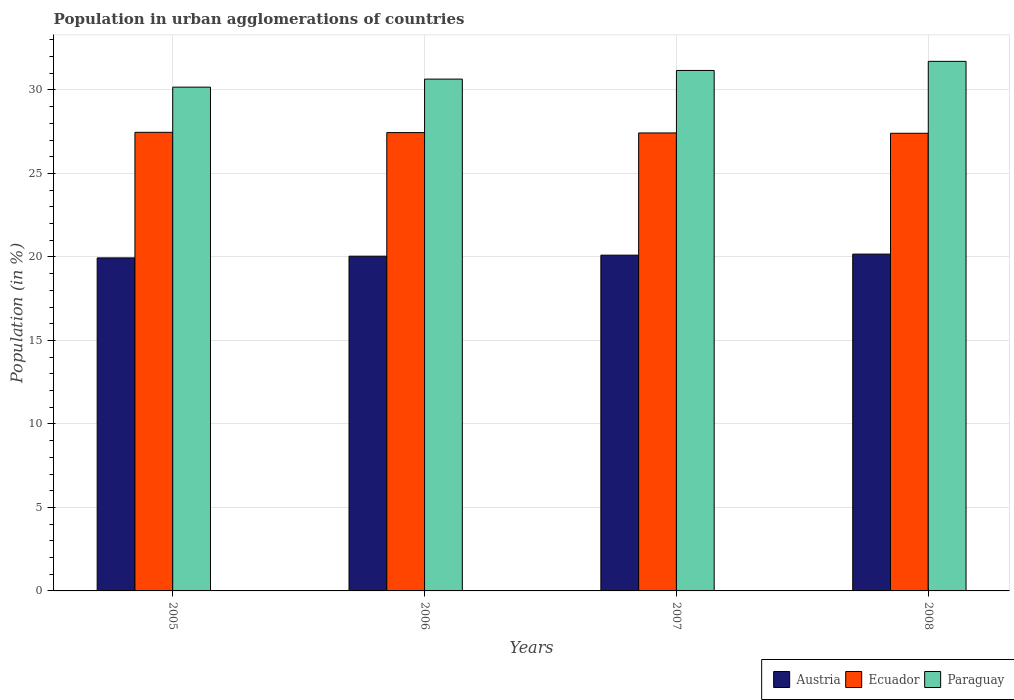How many different coloured bars are there?
Your answer should be compact. 3. How many groups of bars are there?
Your answer should be compact. 4. Are the number of bars on each tick of the X-axis equal?
Your response must be concise. Yes. What is the label of the 2nd group of bars from the left?
Keep it short and to the point. 2006. In how many cases, is the number of bars for a given year not equal to the number of legend labels?
Ensure brevity in your answer.  0. What is the percentage of population in urban agglomerations in Austria in 2007?
Your answer should be compact. 20.11. Across all years, what is the maximum percentage of population in urban agglomerations in Austria?
Your response must be concise. 20.17. Across all years, what is the minimum percentage of population in urban agglomerations in Paraguay?
Offer a terse response. 30.17. In which year was the percentage of population in urban agglomerations in Ecuador maximum?
Your answer should be very brief. 2005. What is the total percentage of population in urban agglomerations in Austria in the graph?
Give a very brief answer. 80.27. What is the difference between the percentage of population in urban agglomerations in Austria in 2005 and that in 2008?
Your response must be concise. -0.23. What is the difference between the percentage of population in urban agglomerations in Paraguay in 2007 and the percentage of population in urban agglomerations in Austria in 2006?
Your response must be concise. 11.12. What is the average percentage of population in urban agglomerations in Ecuador per year?
Give a very brief answer. 27.44. In the year 2005, what is the difference between the percentage of population in urban agglomerations in Ecuador and percentage of population in urban agglomerations in Paraguay?
Keep it short and to the point. -2.71. What is the ratio of the percentage of population in urban agglomerations in Austria in 2005 to that in 2007?
Provide a short and direct response. 0.99. Is the difference between the percentage of population in urban agglomerations in Ecuador in 2007 and 2008 greater than the difference between the percentage of population in urban agglomerations in Paraguay in 2007 and 2008?
Provide a short and direct response. Yes. What is the difference between the highest and the second highest percentage of population in urban agglomerations in Austria?
Offer a very short reply. 0.06. What is the difference between the highest and the lowest percentage of population in urban agglomerations in Ecuador?
Your response must be concise. 0.06. What does the 2nd bar from the right in 2006 represents?
Keep it short and to the point. Ecuador. How many bars are there?
Provide a short and direct response. 12. Are the values on the major ticks of Y-axis written in scientific E-notation?
Give a very brief answer. No. Does the graph contain any zero values?
Keep it short and to the point. No. Where does the legend appear in the graph?
Offer a very short reply. Bottom right. How are the legend labels stacked?
Offer a very short reply. Horizontal. What is the title of the graph?
Your answer should be very brief. Population in urban agglomerations of countries. Does "South Africa" appear as one of the legend labels in the graph?
Provide a succinct answer. No. What is the Population (in %) in Austria in 2005?
Your answer should be very brief. 19.94. What is the Population (in %) in Ecuador in 2005?
Your answer should be compact. 27.46. What is the Population (in %) of Paraguay in 2005?
Offer a terse response. 30.17. What is the Population (in %) in Austria in 2006?
Make the answer very short. 20.05. What is the Population (in %) of Ecuador in 2006?
Your answer should be compact. 27.45. What is the Population (in %) in Paraguay in 2006?
Your response must be concise. 30.65. What is the Population (in %) of Austria in 2007?
Ensure brevity in your answer.  20.11. What is the Population (in %) of Ecuador in 2007?
Your answer should be very brief. 27.43. What is the Population (in %) of Paraguay in 2007?
Your answer should be compact. 31.17. What is the Population (in %) in Austria in 2008?
Offer a terse response. 20.17. What is the Population (in %) in Ecuador in 2008?
Your answer should be very brief. 27.41. What is the Population (in %) of Paraguay in 2008?
Your answer should be compact. 31.72. Across all years, what is the maximum Population (in %) in Austria?
Make the answer very short. 20.17. Across all years, what is the maximum Population (in %) in Ecuador?
Your answer should be very brief. 27.46. Across all years, what is the maximum Population (in %) of Paraguay?
Your response must be concise. 31.72. Across all years, what is the minimum Population (in %) of Austria?
Your answer should be very brief. 19.94. Across all years, what is the minimum Population (in %) in Ecuador?
Your response must be concise. 27.41. Across all years, what is the minimum Population (in %) of Paraguay?
Give a very brief answer. 30.17. What is the total Population (in %) in Austria in the graph?
Offer a very short reply. 80.27. What is the total Population (in %) in Ecuador in the graph?
Your response must be concise. 109.75. What is the total Population (in %) of Paraguay in the graph?
Your answer should be compact. 123.71. What is the difference between the Population (in %) in Austria in 2005 and that in 2006?
Offer a very short reply. -0.1. What is the difference between the Population (in %) in Ecuador in 2005 and that in 2006?
Your response must be concise. 0.02. What is the difference between the Population (in %) of Paraguay in 2005 and that in 2006?
Give a very brief answer. -0.48. What is the difference between the Population (in %) in Austria in 2005 and that in 2007?
Your response must be concise. -0.16. What is the difference between the Population (in %) of Ecuador in 2005 and that in 2007?
Ensure brevity in your answer.  0.04. What is the difference between the Population (in %) of Paraguay in 2005 and that in 2007?
Make the answer very short. -1. What is the difference between the Population (in %) in Austria in 2005 and that in 2008?
Your response must be concise. -0.23. What is the difference between the Population (in %) in Ecuador in 2005 and that in 2008?
Offer a terse response. 0.06. What is the difference between the Population (in %) of Paraguay in 2005 and that in 2008?
Provide a succinct answer. -1.54. What is the difference between the Population (in %) of Austria in 2006 and that in 2007?
Offer a terse response. -0.06. What is the difference between the Population (in %) in Ecuador in 2006 and that in 2007?
Offer a very short reply. 0.02. What is the difference between the Population (in %) in Paraguay in 2006 and that in 2007?
Provide a short and direct response. -0.52. What is the difference between the Population (in %) in Austria in 2006 and that in 2008?
Offer a very short reply. -0.13. What is the difference between the Population (in %) in Ecuador in 2006 and that in 2008?
Keep it short and to the point. 0.04. What is the difference between the Population (in %) in Paraguay in 2006 and that in 2008?
Make the answer very short. -1.06. What is the difference between the Population (in %) in Austria in 2007 and that in 2008?
Make the answer very short. -0.06. What is the difference between the Population (in %) of Ecuador in 2007 and that in 2008?
Make the answer very short. 0.02. What is the difference between the Population (in %) of Paraguay in 2007 and that in 2008?
Offer a very short reply. -0.55. What is the difference between the Population (in %) of Austria in 2005 and the Population (in %) of Ecuador in 2006?
Keep it short and to the point. -7.5. What is the difference between the Population (in %) in Austria in 2005 and the Population (in %) in Paraguay in 2006?
Keep it short and to the point. -10.71. What is the difference between the Population (in %) of Ecuador in 2005 and the Population (in %) of Paraguay in 2006?
Your response must be concise. -3.19. What is the difference between the Population (in %) in Austria in 2005 and the Population (in %) in Ecuador in 2007?
Provide a short and direct response. -7.48. What is the difference between the Population (in %) in Austria in 2005 and the Population (in %) in Paraguay in 2007?
Give a very brief answer. -11.23. What is the difference between the Population (in %) of Ecuador in 2005 and the Population (in %) of Paraguay in 2007?
Your response must be concise. -3.7. What is the difference between the Population (in %) in Austria in 2005 and the Population (in %) in Ecuador in 2008?
Your answer should be compact. -7.46. What is the difference between the Population (in %) of Austria in 2005 and the Population (in %) of Paraguay in 2008?
Offer a terse response. -11.77. What is the difference between the Population (in %) in Ecuador in 2005 and the Population (in %) in Paraguay in 2008?
Keep it short and to the point. -4.25. What is the difference between the Population (in %) in Austria in 2006 and the Population (in %) in Ecuador in 2007?
Your answer should be very brief. -7.38. What is the difference between the Population (in %) of Austria in 2006 and the Population (in %) of Paraguay in 2007?
Ensure brevity in your answer.  -11.12. What is the difference between the Population (in %) in Ecuador in 2006 and the Population (in %) in Paraguay in 2007?
Your answer should be compact. -3.72. What is the difference between the Population (in %) in Austria in 2006 and the Population (in %) in Ecuador in 2008?
Your answer should be very brief. -7.36. What is the difference between the Population (in %) of Austria in 2006 and the Population (in %) of Paraguay in 2008?
Offer a terse response. -11.67. What is the difference between the Population (in %) in Ecuador in 2006 and the Population (in %) in Paraguay in 2008?
Keep it short and to the point. -4.27. What is the difference between the Population (in %) in Austria in 2007 and the Population (in %) in Ecuador in 2008?
Provide a short and direct response. -7.3. What is the difference between the Population (in %) in Austria in 2007 and the Population (in %) in Paraguay in 2008?
Provide a succinct answer. -11.61. What is the difference between the Population (in %) in Ecuador in 2007 and the Population (in %) in Paraguay in 2008?
Provide a succinct answer. -4.29. What is the average Population (in %) in Austria per year?
Provide a succinct answer. 20.07. What is the average Population (in %) in Ecuador per year?
Offer a very short reply. 27.44. What is the average Population (in %) in Paraguay per year?
Ensure brevity in your answer.  30.93. In the year 2005, what is the difference between the Population (in %) of Austria and Population (in %) of Ecuador?
Your answer should be very brief. -7.52. In the year 2005, what is the difference between the Population (in %) in Austria and Population (in %) in Paraguay?
Provide a succinct answer. -10.23. In the year 2005, what is the difference between the Population (in %) of Ecuador and Population (in %) of Paraguay?
Offer a very short reply. -2.71. In the year 2006, what is the difference between the Population (in %) in Austria and Population (in %) in Ecuador?
Provide a succinct answer. -7.4. In the year 2006, what is the difference between the Population (in %) in Austria and Population (in %) in Paraguay?
Make the answer very short. -10.61. In the year 2006, what is the difference between the Population (in %) of Ecuador and Population (in %) of Paraguay?
Provide a short and direct response. -3.2. In the year 2007, what is the difference between the Population (in %) in Austria and Population (in %) in Ecuador?
Make the answer very short. -7.32. In the year 2007, what is the difference between the Population (in %) of Austria and Population (in %) of Paraguay?
Keep it short and to the point. -11.06. In the year 2007, what is the difference between the Population (in %) in Ecuador and Population (in %) in Paraguay?
Keep it short and to the point. -3.74. In the year 2008, what is the difference between the Population (in %) of Austria and Population (in %) of Ecuador?
Give a very brief answer. -7.24. In the year 2008, what is the difference between the Population (in %) of Austria and Population (in %) of Paraguay?
Give a very brief answer. -11.54. In the year 2008, what is the difference between the Population (in %) of Ecuador and Population (in %) of Paraguay?
Offer a terse response. -4.31. What is the ratio of the Population (in %) in Austria in 2005 to that in 2006?
Keep it short and to the point. 0.99. What is the ratio of the Population (in %) of Ecuador in 2005 to that in 2006?
Make the answer very short. 1. What is the ratio of the Population (in %) in Paraguay in 2005 to that in 2006?
Give a very brief answer. 0.98. What is the ratio of the Population (in %) of Austria in 2005 to that in 2008?
Provide a succinct answer. 0.99. What is the ratio of the Population (in %) of Ecuador in 2005 to that in 2008?
Your response must be concise. 1. What is the ratio of the Population (in %) in Paraguay in 2005 to that in 2008?
Offer a very short reply. 0.95. What is the ratio of the Population (in %) in Austria in 2006 to that in 2007?
Keep it short and to the point. 1. What is the ratio of the Population (in %) in Paraguay in 2006 to that in 2007?
Provide a short and direct response. 0.98. What is the ratio of the Population (in %) in Austria in 2006 to that in 2008?
Your answer should be very brief. 0.99. What is the ratio of the Population (in %) in Ecuador in 2006 to that in 2008?
Your response must be concise. 1. What is the ratio of the Population (in %) of Paraguay in 2006 to that in 2008?
Provide a short and direct response. 0.97. What is the ratio of the Population (in %) of Austria in 2007 to that in 2008?
Provide a short and direct response. 1. What is the ratio of the Population (in %) of Paraguay in 2007 to that in 2008?
Offer a terse response. 0.98. What is the difference between the highest and the second highest Population (in %) of Austria?
Your response must be concise. 0.06. What is the difference between the highest and the second highest Population (in %) of Ecuador?
Your response must be concise. 0.02. What is the difference between the highest and the second highest Population (in %) in Paraguay?
Your answer should be compact. 0.55. What is the difference between the highest and the lowest Population (in %) of Austria?
Offer a very short reply. 0.23. What is the difference between the highest and the lowest Population (in %) of Ecuador?
Offer a very short reply. 0.06. What is the difference between the highest and the lowest Population (in %) in Paraguay?
Make the answer very short. 1.54. 